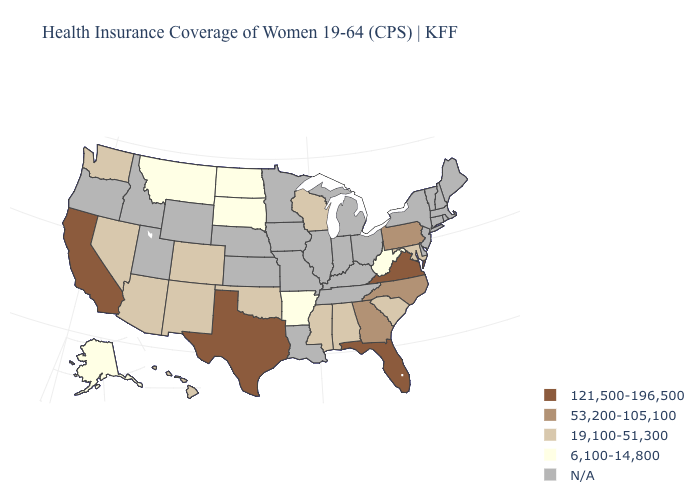What is the value of Vermont?
Be succinct. N/A. What is the highest value in the Northeast ?
Answer briefly. 53,200-105,100. Name the states that have a value in the range 6,100-14,800?
Give a very brief answer. Alaska, Arkansas, Montana, North Dakota, South Dakota, West Virginia. Name the states that have a value in the range N/A?
Give a very brief answer. Connecticut, Delaware, Idaho, Illinois, Indiana, Iowa, Kansas, Kentucky, Louisiana, Maine, Massachusetts, Michigan, Minnesota, Missouri, Nebraska, New Hampshire, New Jersey, New York, Ohio, Oregon, Rhode Island, Tennessee, Utah, Vermont, Wyoming. Name the states that have a value in the range 121,500-196,500?
Short answer required. California, Florida, Texas, Virginia. Name the states that have a value in the range 121,500-196,500?
Give a very brief answer. California, Florida, Texas, Virginia. Which states have the lowest value in the USA?
Be succinct. Alaska, Arkansas, Montana, North Dakota, South Dakota, West Virginia. Which states hav the highest value in the Northeast?
Concise answer only. Pennsylvania. Does Pennsylvania have the highest value in the USA?
Write a very short answer. No. What is the value of Ohio?
Answer briefly. N/A. Name the states that have a value in the range 6,100-14,800?
Write a very short answer. Alaska, Arkansas, Montana, North Dakota, South Dakota, West Virginia. What is the highest value in the Northeast ?
Give a very brief answer. 53,200-105,100. Does North Dakota have the lowest value in the USA?
Be succinct. Yes. 